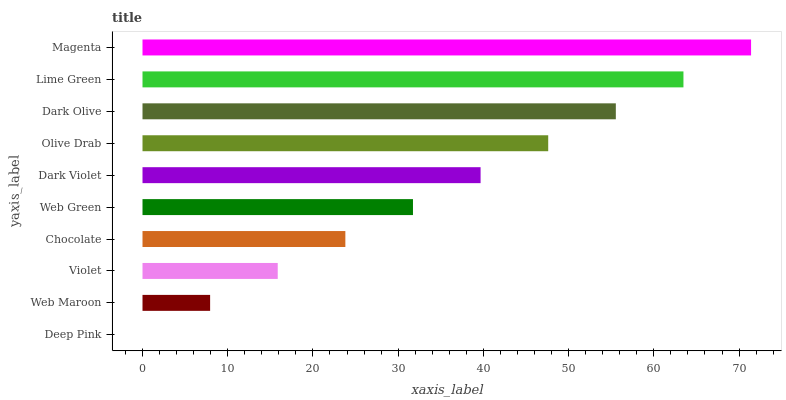Is Deep Pink the minimum?
Answer yes or no. Yes. Is Magenta the maximum?
Answer yes or no. Yes. Is Web Maroon the minimum?
Answer yes or no. No. Is Web Maroon the maximum?
Answer yes or no. No. Is Web Maroon greater than Deep Pink?
Answer yes or no. Yes. Is Deep Pink less than Web Maroon?
Answer yes or no. Yes. Is Deep Pink greater than Web Maroon?
Answer yes or no. No. Is Web Maroon less than Deep Pink?
Answer yes or no. No. Is Dark Violet the high median?
Answer yes or no. Yes. Is Web Green the low median?
Answer yes or no. Yes. Is Lime Green the high median?
Answer yes or no. No. Is Lime Green the low median?
Answer yes or no. No. 